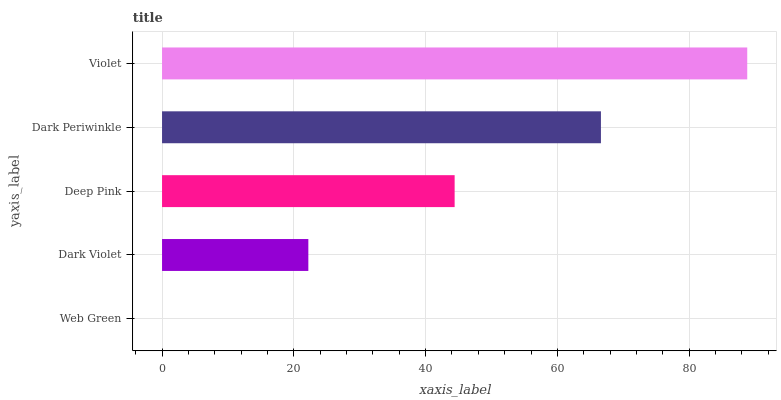Is Web Green the minimum?
Answer yes or no. Yes. Is Violet the maximum?
Answer yes or no. Yes. Is Dark Violet the minimum?
Answer yes or no. No. Is Dark Violet the maximum?
Answer yes or no. No. Is Dark Violet greater than Web Green?
Answer yes or no. Yes. Is Web Green less than Dark Violet?
Answer yes or no. Yes. Is Web Green greater than Dark Violet?
Answer yes or no. No. Is Dark Violet less than Web Green?
Answer yes or no. No. Is Deep Pink the high median?
Answer yes or no. Yes. Is Deep Pink the low median?
Answer yes or no. Yes. Is Dark Violet the high median?
Answer yes or no. No. Is Violet the low median?
Answer yes or no. No. 